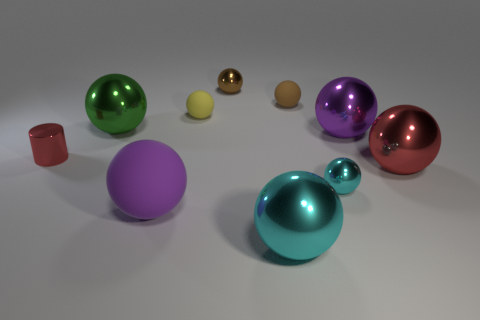There is a purple sphere that is made of the same material as the large red sphere; what size is it? The purple sphere, sharing the same material and reflective qualities as the large red sphere, is medium in size compared to the other objects in the scene. It appears to be smaller than the large spheres but notably larger than the smallest ones. 